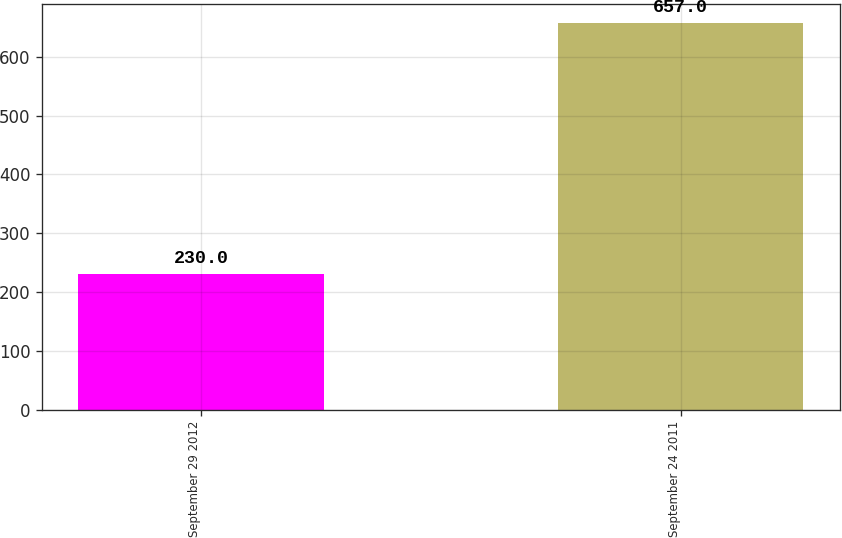Convert chart. <chart><loc_0><loc_0><loc_500><loc_500><bar_chart><fcel>September 29 2012<fcel>September 24 2011<nl><fcel>230<fcel>657<nl></chart> 